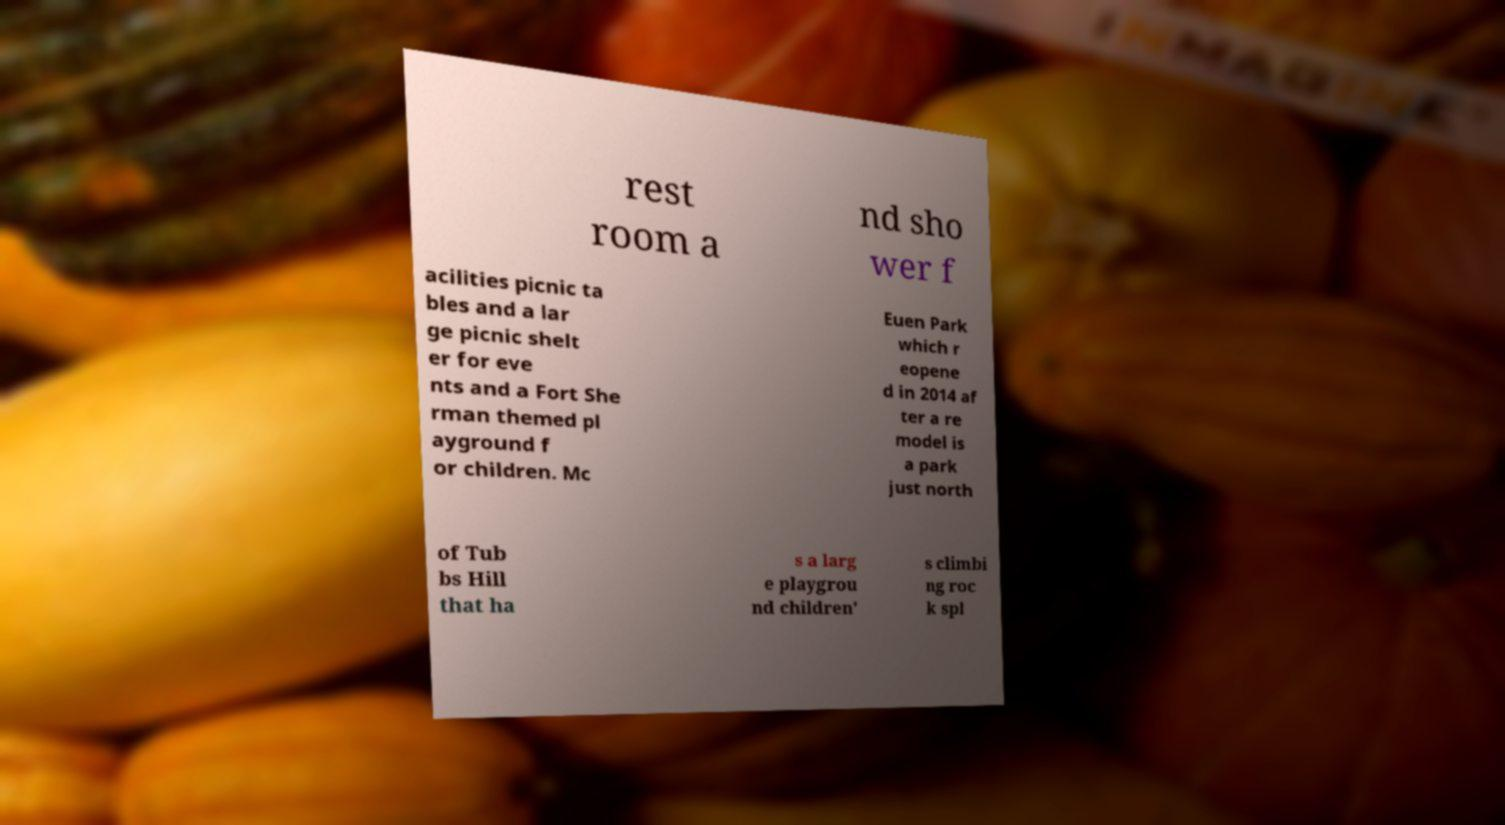What messages or text are displayed in this image? I need them in a readable, typed format. rest room a nd sho wer f acilities picnic ta bles and a lar ge picnic shelt er for eve nts and a Fort She rman themed pl ayground f or children. Mc Euen Park which r eopene d in 2014 af ter a re model is a park just north of Tub bs Hill that ha s a larg e playgrou nd children' s climbi ng roc k spl 